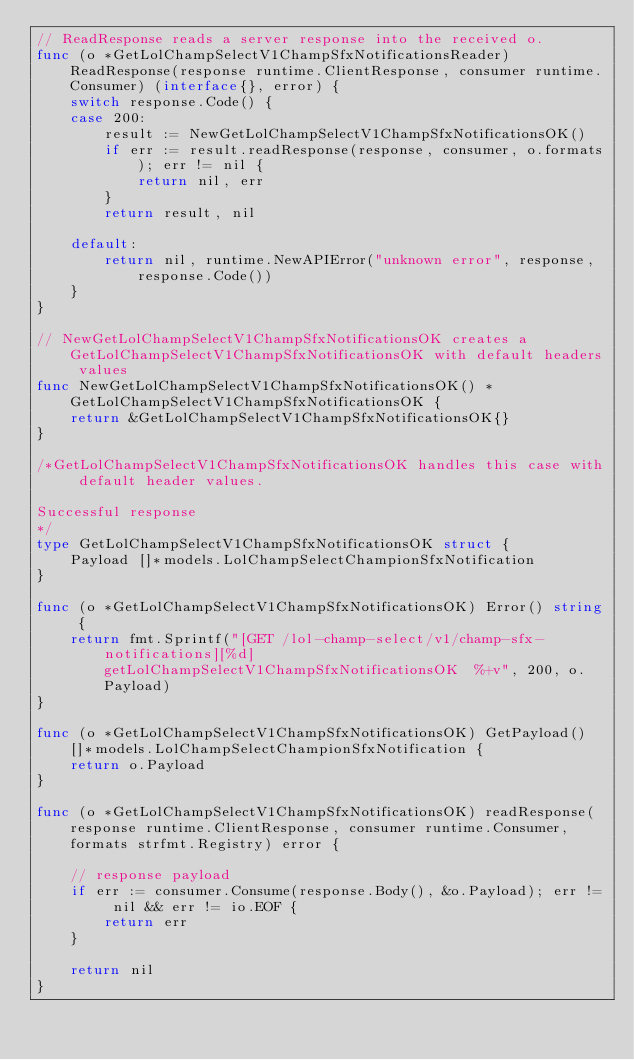Convert code to text. <code><loc_0><loc_0><loc_500><loc_500><_Go_>// ReadResponse reads a server response into the received o.
func (o *GetLolChampSelectV1ChampSfxNotificationsReader) ReadResponse(response runtime.ClientResponse, consumer runtime.Consumer) (interface{}, error) {
	switch response.Code() {
	case 200:
		result := NewGetLolChampSelectV1ChampSfxNotificationsOK()
		if err := result.readResponse(response, consumer, o.formats); err != nil {
			return nil, err
		}
		return result, nil

	default:
		return nil, runtime.NewAPIError("unknown error", response, response.Code())
	}
}

// NewGetLolChampSelectV1ChampSfxNotificationsOK creates a GetLolChampSelectV1ChampSfxNotificationsOK with default headers values
func NewGetLolChampSelectV1ChampSfxNotificationsOK() *GetLolChampSelectV1ChampSfxNotificationsOK {
	return &GetLolChampSelectV1ChampSfxNotificationsOK{}
}

/*GetLolChampSelectV1ChampSfxNotificationsOK handles this case with default header values.

Successful response
*/
type GetLolChampSelectV1ChampSfxNotificationsOK struct {
	Payload []*models.LolChampSelectChampionSfxNotification
}

func (o *GetLolChampSelectV1ChampSfxNotificationsOK) Error() string {
	return fmt.Sprintf("[GET /lol-champ-select/v1/champ-sfx-notifications][%d] getLolChampSelectV1ChampSfxNotificationsOK  %+v", 200, o.Payload)
}

func (o *GetLolChampSelectV1ChampSfxNotificationsOK) GetPayload() []*models.LolChampSelectChampionSfxNotification {
	return o.Payload
}

func (o *GetLolChampSelectV1ChampSfxNotificationsOK) readResponse(response runtime.ClientResponse, consumer runtime.Consumer, formats strfmt.Registry) error {

	// response payload
	if err := consumer.Consume(response.Body(), &o.Payload); err != nil && err != io.EOF {
		return err
	}

	return nil
}
</code> 